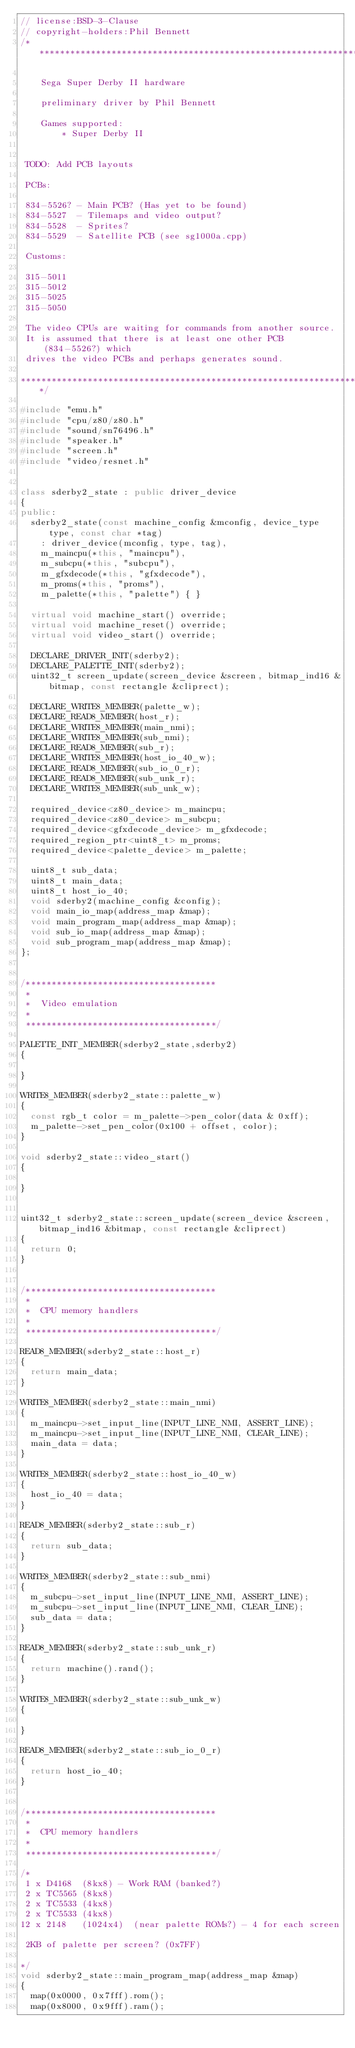<code> <loc_0><loc_0><loc_500><loc_500><_C++_>// license:BSD-3-Clause
// copyright-holders:Phil Bennett
/***************************************************************************

    Sega Super Derby II hardware

    preliminary driver by Phil Bennett

    Games supported:
        * Super Derby II


 TODO: Add PCB layouts

 PCBs:

 834-5526? - Main PCB? (Has yet to be found)
 834-5527  - Tilemaps and video output?
 834-5528  - Sprites?
 834-5529  - Satellite PCB (see sg1000a.cpp)

 Customs:

 315-5011
 315-5012
 315-5025
 315-5050

 The video CPUs are waiting for commands from another source.
 It is assumed that there is at least one other PCB (834-5526?) which
 drives the video PCBs and perhaps generates sound.

***************************************************************************/

#include "emu.h"
#include "cpu/z80/z80.h"
#include "sound/sn76496.h"
#include "speaker.h"
#include "screen.h"
#include "video/resnet.h"


class sderby2_state : public driver_device
{
public:
	sderby2_state(const machine_config &mconfig, device_type type, const char *tag)
		: driver_device(mconfig, type, tag),
		m_maincpu(*this, "maincpu"),
		m_subcpu(*this, "subcpu"),
		m_gfxdecode(*this, "gfxdecode"),
		m_proms(*this, "proms"),
		m_palette(*this, "palette") { }

	virtual void machine_start() override;
	virtual void machine_reset() override;
	virtual void video_start() override;

	DECLARE_DRIVER_INIT(sderby2);
	DECLARE_PALETTE_INIT(sderby2);
	uint32_t screen_update(screen_device &screen, bitmap_ind16 &bitmap, const rectangle &cliprect);

	DECLARE_WRITE8_MEMBER(palette_w);
	DECLARE_READ8_MEMBER(host_r);
	DECLARE_WRITE8_MEMBER(main_nmi);
	DECLARE_WRITE8_MEMBER(sub_nmi);
	DECLARE_READ8_MEMBER(sub_r);
	DECLARE_WRITE8_MEMBER(host_io_40_w);
	DECLARE_READ8_MEMBER(sub_io_0_r);
	DECLARE_READ8_MEMBER(sub_unk_r);
	DECLARE_WRITE8_MEMBER(sub_unk_w);

	required_device<z80_device> m_maincpu;
	required_device<z80_device> m_subcpu;
	required_device<gfxdecode_device> m_gfxdecode;
	required_region_ptr<uint8_t> m_proms;
	required_device<palette_device> m_palette;

	uint8_t sub_data;
	uint8_t main_data;
	uint8_t host_io_40;
	void sderby2(machine_config &config);
	void main_io_map(address_map &map);
	void main_program_map(address_map &map);
	void sub_io_map(address_map &map);
	void sub_program_map(address_map &map);
};


/*************************************
 *
 *  Video emulation
 *
 *************************************/

PALETTE_INIT_MEMBER(sderby2_state,sderby2)
{

}

WRITE8_MEMBER(sderby2_state::palette_w)
{
	const rgb_t color = m_palette->pen_color(data & 0xff);
	m_palette->set_pen_color(0x100 + offset, color);
}

void sderby2_state::video_start()
{

}


uint32_t sderby2_state::screen_update(screen_device &screen, bitmap_ind16 &bitmap, const rectangle &cliprect)
{
	return 0;
}


/*************************************
 *
 *  CPU memory handlers
 *
 *************************************/

READ8_MEMBER(sderby2_state::host_r)
{
	return main_data;
}

WRITE8_MEMBER(sderby2_state::main_nmi)
{
	m_maincpu->set_input_line(INPUT_LINE_NMI, ASSERT_LINE);
	m_maincpu->set_input_line(INPUT_LINE_NMI, CLEAR_LINE);
	main_data = data;
}

WRITE8_MEMBER(sderby2_state::host_io_40_w)
{
	host_io_40 = data;
}

READ8_MEMBER(sderby2_state::sub_r)
{
	return sub_data;
}

WRITE8_MEMBER(sderby2_state::sub_nmi)
{
	m_subcpu->set_input_line(INPUT_LINE_NMI, ASSERT_LINE);
	m_subcpu->set_input_line(INPUT_LINE_NMI, CLEAR_LINE);
	sub_data = data;
}

READ8_MEMBER(sderby2_state::sub_unk_r)
{
	return machine().rand();
}

WRITE8_MEMBER(sderby2_state::sub_unk_w)
{

}

READ8_MEMBER(sderby2_state::sub_io_0_r)
{
	return host_io_40;
}


/*************************************
 *
 *  CPU memory handlers
 *
 *************************************/

/*
 1 x D4168  (8kx8) - Work RAM (banked?)
 2 x TC5565 (8kx8)
 2 x TC5533 (4kx8)
 2 x TC5533 (4kx8)
12 x 2148   (1024x4)  (near palette ROMs?) - 4 for each screen

 2KB of palette per screen? (0x7FF)

*/
void sderby2_state::main_program_map(address_map &map)
{
	map(0x0000, 0x7fff).rom();
	map(0x8000, 0x9fff).ram();</code> 